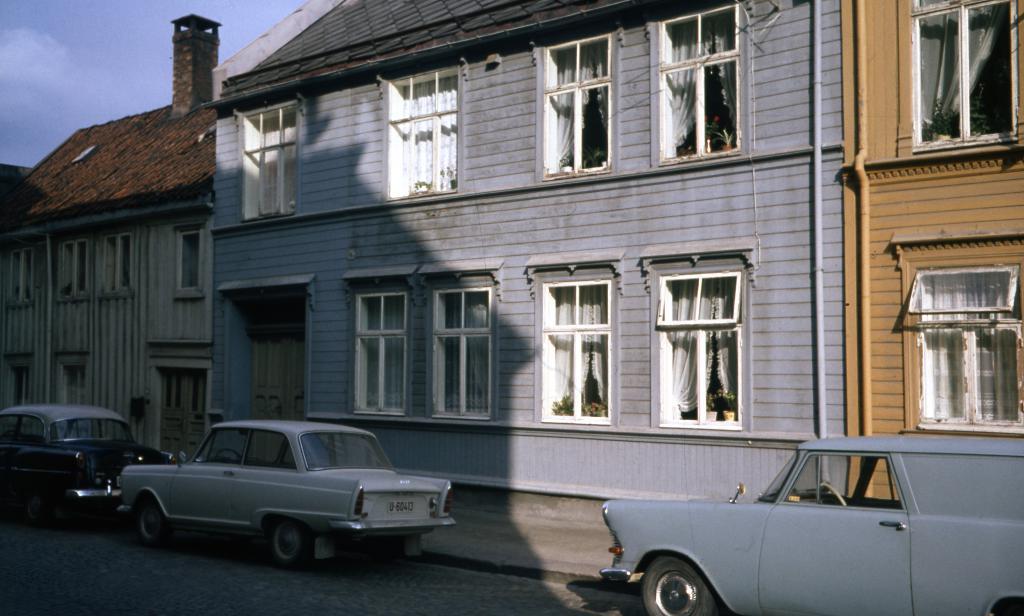Could you give a brief overview of what you see in this image? In this image in the center there are cars on the road. In the background there are buildings and there are windows which are white in colour and the sky is cloudy. 